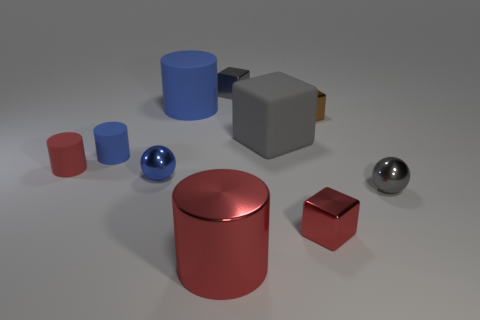Subtract all balls. How many objects are left? 8 Add 4 small brown objects. How many small brown objects exist? 5 Subtract 0 yellow blocks. How many objects are left? 10 Subtract all big red metal things. Subtract all tiny gray spheres. How many objects are left? 8 Add 3 big shiny objects. How many big shiny objects are left? 4 